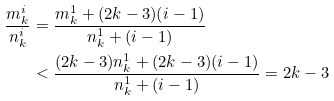<formula> <loc_0><loc_0><loc_500><loc_500>\frac { m ^ { i } _ { k } } { n ^ { i } _ { k } } & = \frac { m ^ { 1 } _ { k } + ( 2 k - 3 ) ( i - 1 ) } { n ^ { 1 } _ { k } + ( i - 1 ) } \\ & < \frac { ( 2 k - 3 ) n ^ { 1 } _ { k } + ( 2 k - 3 ) ( i - 1 ) } { n ^ { 1 } _ { k } + ( i - 1 ) } = 2 k - 3 \\</formula> 